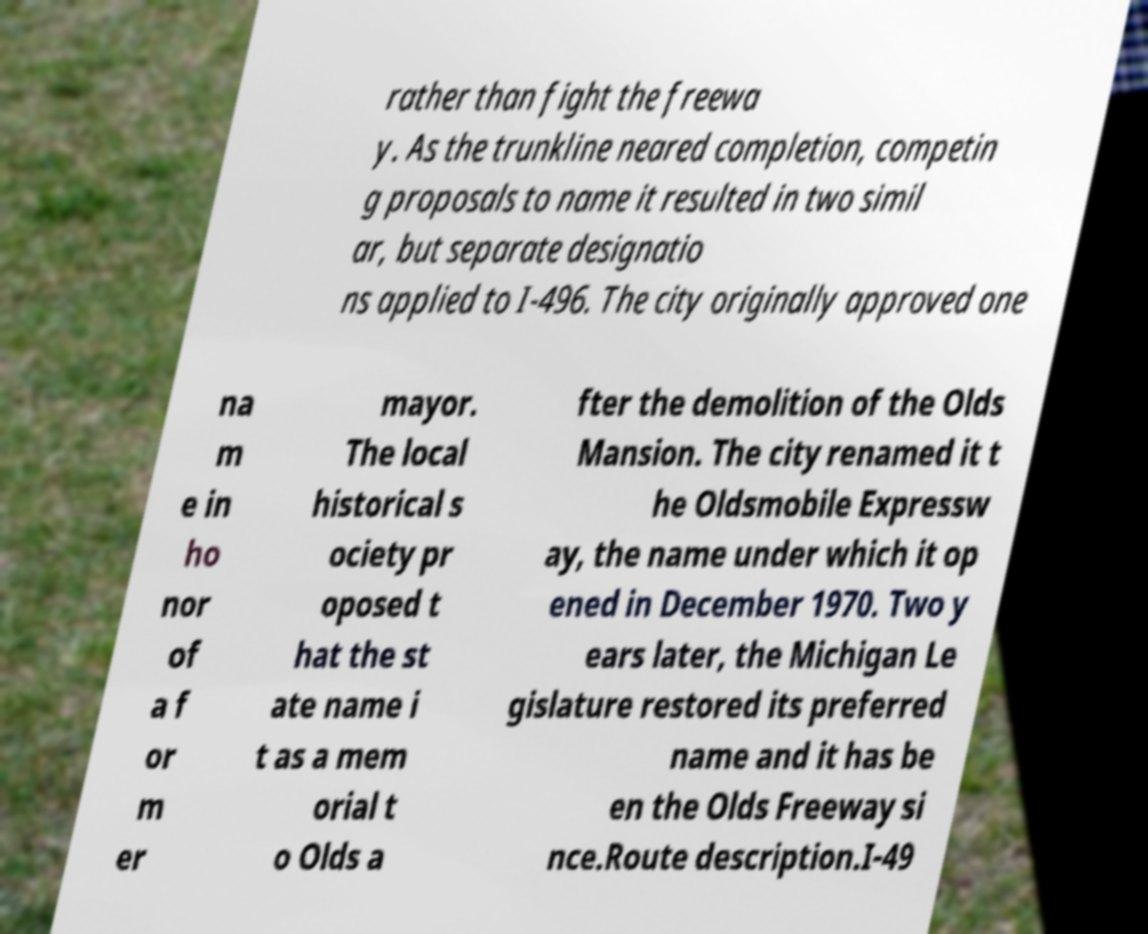Could you assist in decoding the text presented in this image and type it out clearly? rather than fight the freewa y. As the trunkline neared completion, competin g proposals to name it resulted in two simil ar, but separate designatio ns applied to I-496. The city originally approved one na m e in ho nor of a f or m er mayor. The local historical s ociety pr oposed t hat the st ate name i t as a mem orial t o Olds a fter the demolition of the Olds Mansion. The city renamed it t he Oldsmobile Expressw ay, the name under which it op ened in December 1970. Two y ears later, the Michigan Le gislature restored its preferred name and it has be en the Olds Freeway si nce.Route description.I-49 